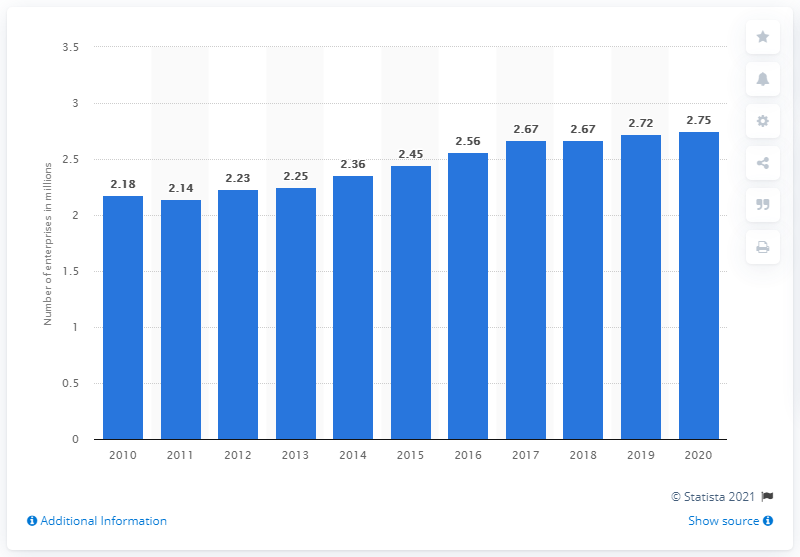Point out several critical features in this image. In 2018, the number of business enterprises based in the UK was 2.72 million. In 2020, there were approximately 2.75 value-added tax business enterprises based in the UK. 